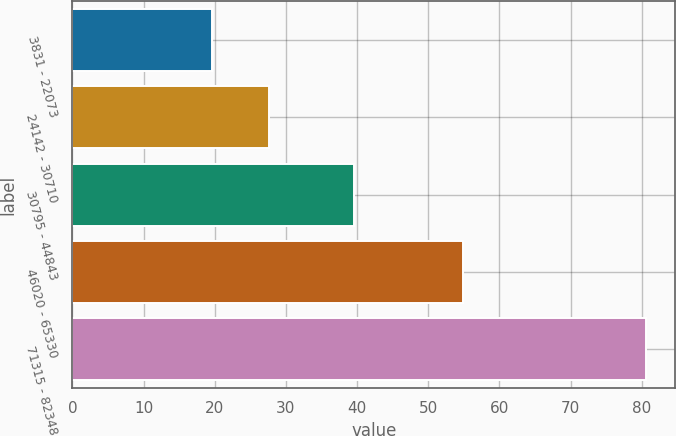Convert chart to OTSL. <chart><loc_0><loc_0><loc_500><loc_500><bar_chart><fcel>3831 - 22073<fcel>24142 - 30710<fcel>30795 - 44843<fcel>46020 - 65330<fcel>71315 - 82348<nl><fcel>19.66<fcel>27.62<fcel>39.62<fcel>54.84<fcel>80.64<nl></chart> 